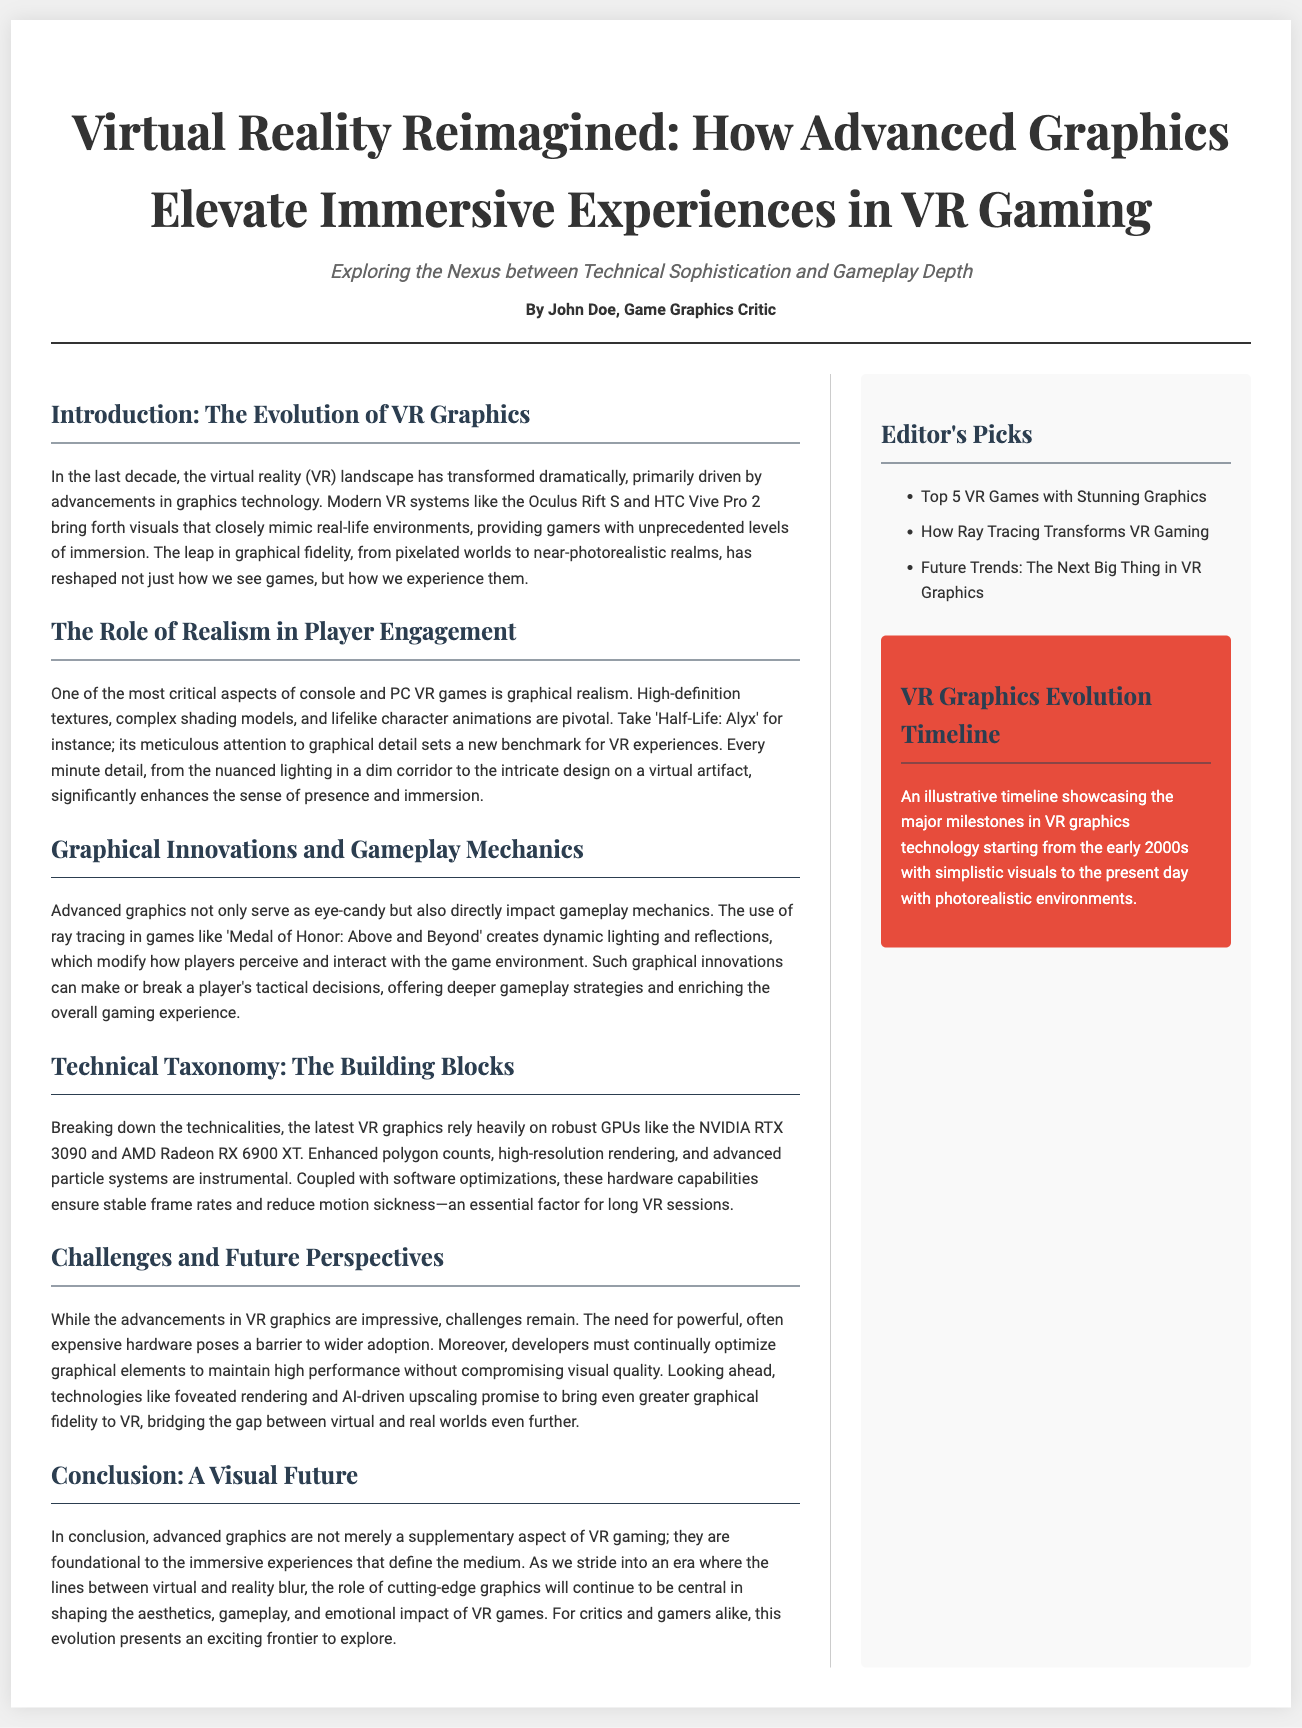What is the title of the article? The title can be found at the top of the document and defines the main subject of the article.
Answer: Virtual Reality Reimagined: How Advanced Graphics Elevate Immersive Experiences in VR Gaming Who is the author of the article? The author is credited at the end of the header section, indicating who wrote the piece.
Answer: John Doe What gaming system is mentioned as an example of modern VR technology? The document provides specific examples to illustrate advancements in VR technology.
Answer: Oculus Rift S Which game is indicated as setting a benchmark for VR experiences? The game is highlighted in the section discussing realism and is an example to show graphical detail excellence.
Answer: Half-Life: Alyx What is a technological feature that affects gameplay mechanics? The document describes specifics about how certain graphical technologies impact the experience of games.
Answer: Ray tracing What are the two GPUs mentioned in the technical taxonomy section? The document lists the names of specific powerful GPUs relevant to VR graphics.
Answer: NVIDIA RTX 3090 and AMD Radeon RX 6900 XT What is one challenge mentioned regarding advancements in VR graphics? The article points out a barrier to wider adoption of VR technology based on requirements for hardware.
Answer: Expensive hardware What future technology is predicted to enhance graphical fidelity in VR? The document mentions specific upcoming technologies that will further improve VR graphics in the future.
Answer: Foveated rendering What type of content is listed under the Editor's Picks section? The sidebar categorizes specific articles, providing additional resources related to the main topic.
Answer: Top 5 VR Games with Stunning Graphics 